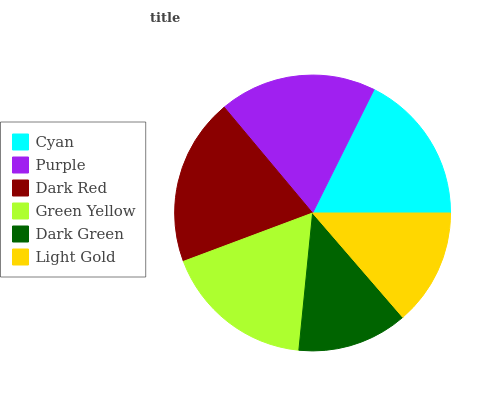Is Dark Green the minimum?
Answer yes or no. Yes. Is Dark Red the maximum?
Answer yes or no. Yes. Is Purple the minimum?
Answer yes or no. No. Is Purple the maximum?
Answer yes or no. No. Is Purple greater than Cyan?
Answer yes or no. Yes. Is Cyan less than Purple?
Answer yes or no. Yes. Is Cyan greater than Purple?
Answer yes or no. No. Is Purple less than Cyan?
Answer yes or no. No. Is Green Yellow the high median?
Answer yes or no. Yes. Is Cyan the low median?
Answer yes or no. Yes. Is Dark Green the high median?
Answer yes or no. No. Is Purple the low median?
Answer yes or no. No. 